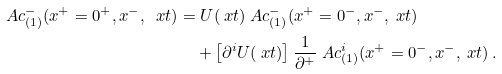Convert formula to latex. <formula><loc_0><loc_0><loc_500><loc_500>\ A c _ { ( 1 ) } ^ { - } ( x ^ { + } = 0 ^ { + } , x ^ { - } , \ x t ) & = U ( \ x t ) \ A c _ { ( 1 ) } ^ { - } ( x ^ { + } = 0 ^ { - } , x ^ { - } , \ x t ) \\ & \quad + \left [ \partial ^ { i } U ( \ x t ) \right ] \frac { 1 } { \partial ^ { + } } \ A c _ { ( 1 ) } ^ { i } ( x ^ { + } = 0 ^ { - } , x ^ { - } , \ x t ) \, .</formula> 